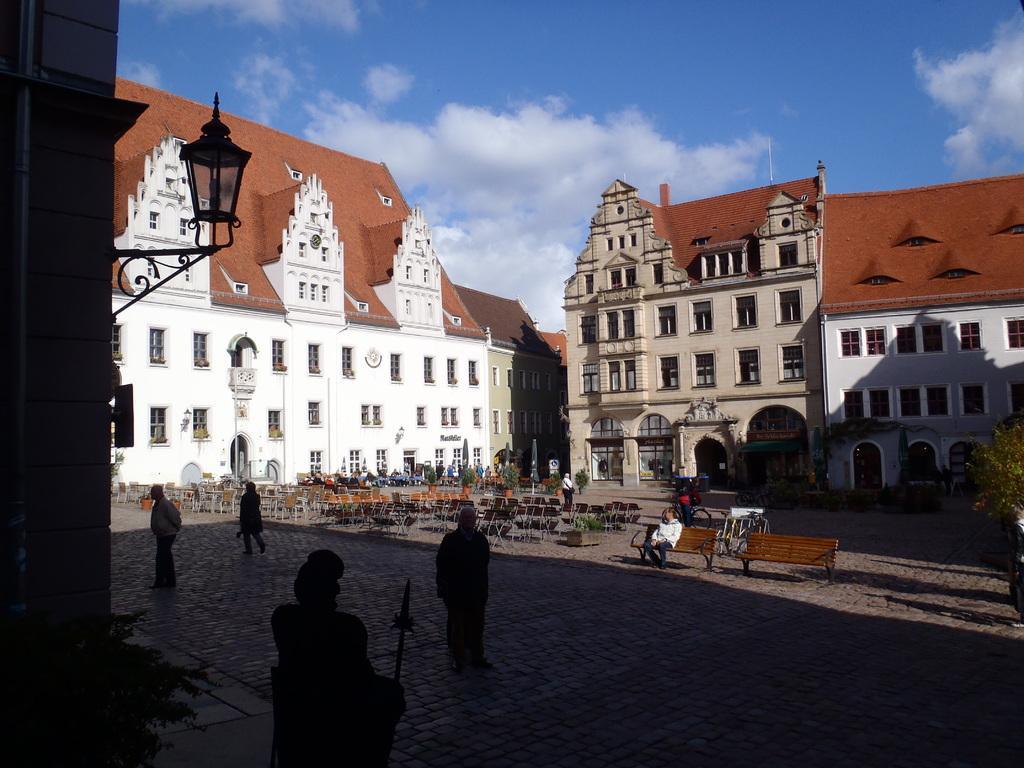Describe this image in one or two sentences. In the picture i can see some persons standing and some are sitting on benches and in the background i can see some buildings, top of the picture there is clear sky. 